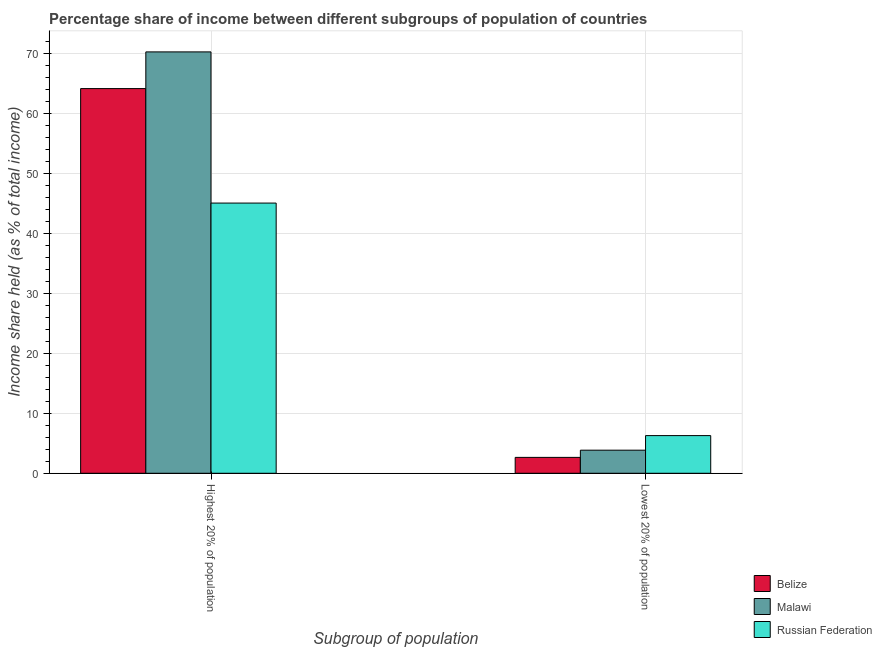How many different coloured bars are there?
Your response must be concise. 3. Are the number of bars on each tick of the X-axis equal?
Your response must be concise. Yes. How many bars are there on the 2nd tick from the left?
Your response must be concise. 3. What is the label of the 2nd group of bars from the left?
Ensure brevity in your answer.  Lowest 20% of population. What is the income share held by highest 20% of the population in Belize?
Your answer should be very brief. 64.15. Across all countries, what is the maximum income share held by highest 20% of the population?
Your response must be concise. 70.27. Across all countries, what is the minimum income share held by highest 20% of the population?
Your answer should be very brief. 45.06. In which country was the income share held by lowest 20% of the population maximum?
Make the answer very short. Russian Federation. In which country was the income share held by highest 20% of the population minimum?
Give a very brief answer. Russian Federation. What is the total income share held by lowest 20% of the population in the graph?
Keep it short and to the point. 12.78. What is the difference between the income share held by lowest 20% of the population in Malawi and that in Russian Federation?
Offer a terse response. -2.43. What is the difference between the income share held by lowest 20% of the population in Malawi and the income share held by highest 20% of the population in Belize?
Your answer should be compact. -60.3. What is the average income share held by highest 20% of the population per country?
Your response must be concise. 59.83. What is the difference between the income share held by highest 20% of the population and income share held by lowest 20% of the population in Malawi?
Provide a succinct answer. 66.42. What is the ratio of the income share held by highest 20% of the population in Malawi to that in Russian Federation?
Your answer should be compact. 1.56. Is the income share held by highest 20% of the population in Russian Federation less than that in Malawi?
Give a very brief answer. Yes. In how many countries, is the income share held by highest 20% of the population greater than the average income share held by highest 20% of the population taken over all countries?
Your response must be concise. 2. What does the 1st bar from the left in Highest 20% of population represents?
Give a very brief answer. Belize. What does the 1st bar from the right in Lowest 20% of population represents?
Offer a very short reply. Russian Federation. Are all the bars in the graph horizontal?
Keep it short and to the point. No. What is the difference between two consecutive major ticks on the Y-axis?
Give a very brief answer. 10. Are the values on the major ticks of Y-axis written in scientific E-notation?
Your answer should be very brief. No. What is the title of the graph?
Your response must be concise. Percentage share of income between different subgroups of population of countries. What is the label or title of the X-axis?
Provide a short and direct response. Subgroup of population. What is the label or title of the Y-axis?
Your response must be concise. Income share held (as % of total income). What is the Income share held (as % of total income) of Belize in Highest 20% of population?
Offer a terse response. 64.15. What is the Income share held (as % of total income) in Malawi in Highest 20% of population?
Provide a succinct answer. 70.27. What is the Income share held (as % of total income) of Russian Federation in Highest 20% of population?
Provide a succinct answer. 45.06. What is the Income share held (as % of total income) of Belize in Lowest 20% of population?
Offer a very short reply. 2.65. What is the Income share held (as % of total income) in Malawi in Lowest 20% of population?
Ensure brevity in your answer.  3.85. What is the Income share held (as % of total income) in Russian Federation in Lowest 20% of population?
Your answer should be very brief. 6.28. Across all Subgroup of population, what is the maximum Income share held (as % of total income) of Belize?
Make the answer very short. 64.15. Across all Subgroup of population, what is the maximum Income share held (as % of total income) of Malawi?
Offer a terse response. 70.27. Across all Subgroup of population, what is the maximum Income share held (as % of total income) of Russian Federation?
Offer a terse response. 45.06. Across all Subgroup of population, what is the minimum Income share held (as % of total income) in Belize?
Your answer should be compact. 2.65. Across all Subgroup of population, what is the minimum Income share held (as % of total income) in Malawi?
Provide a short and direct response. 3.85. Across all Subgroup of population, what is the minimum Income share held (as % of total income) of Russian Federation?
Provide a succinct answer. 6.28. What is the total Income share held (as % of total income) of Belize in the graph?
Give a very brief answer. 66.8. What is the total Income share held (as % of total income) in Malawi in the graph?
Make the answer very short. 74.12. What is the total Income share held (as % of total income) of Russian Federation in the graph?
Provide a short and direct response. 51.34. What is the difference between the Income share held (as % of total income) of Belize in Highest 20% of population and that in Lowest 20% of population?
Your answer should be very brief. 61.5. What is the difference between the Income share held (as % of total income) in Malawi in Highest 20% of population and that in Lowest 20% of population?
Give a very brief answer. 66.42. What is the difference between the Income share held (as % of total income) of Russian Federation in Highest 20% of population and that in Lowest 20% of population?
Offer a terse response. 38.78. What is the difference between the Income share held (as % of total income) in Belize in Highest 20% of population and the Income share held (as % of total income) in Malawi in Lowest 20% of population?
Provide a succinct answer. 60.3. What is the difference between the Income share held (as % of total income) in Belize in Highest 20% of population and the Income share held (as % of total income) in Russian Federation in Lowest 20% of population?
Your response must be concise. 57.87. What is the difference between the Income share held (as % of total income) of Malawi in Highest 20% of population and the Income share held (as % of total income) of Russian Federation in Lowest 20% of population?
Keep it short and to the point. 63.99. What is the average Income share held (as % of total income) in Belize per Subgroup of population?
Your answer should be very brief. 33.4. What is the average Income share held (as % of total income) in Malawi per Subgroup of population?
Offer a terse response. 37.06. What is the average Income share held (as % of total income) in Russian Federation per Subgroup of population?
Provide a succinct answer. 25.67. What is the difference between the Income share held (as % of total income) of Belize and Income share held (as % of total income) of Malawi in Highest 20% of population?
Ensure brevity in your answer.  -6.12. What is the difference between the Income share held (as % of total income) of Belize and Income share held (as % of total income) of Russian Federation in Highest 20% of population?
Offer a terse response. 19.09. What is the difference between the Income share held (as % of total income) in Malawi and Income share held (as % of total income) in Russian Federation in Highest 20% of population?
Ensure brevity in your answer.  25.21. What is the difference between the Income share held (as % of total income) in Belize and Income share held (as % of total income) in Malawi in Lowest 20% of population?
Keep it short and to the point. -1.2. What is the difference between the Income share held (as % of total income) in Belize and Income share held (as % of total income) in Russian Federation in Lowest 20% of population?
Give a very brief answer. -3.63. What is the difference between the Income share held (as % of total income) of Malawi and Income share held (as % of total income) of Russian Federation in Lowest 20% of population?
Offer a terse response. -2.43. What is the ratio of the Income share held (as % of total income) of Belize in Highest 20% of population to that in Lowest 20% of population?
Your answer should be compact. 24.21. What is the ratio of the Income share held (as % of total income) in Malawi in Highest 20% of population to that in Lowest 20% of population?
Offer a very short reply. 18.25. What is the ratio of the Income share held (as % of total income) in Russian Federation in Highest 20% of population to that in Lowest 20% of population?
Provide a succinct answer. 7.18. What is the difference between the highest and the second highest Income share held (as % of total income) of Belize?
Provide a short and direct response. 61.5. What is the difference between the highest and the second highest Income share held (as % of total income) in Malawi?
Your answer should be very brief. 66.42. What is the difference between the highest and the second highest Income share held (as % of total income) in Russian Federation?
Give a very brief answer. 38.78. What is the difference between the highest and the lowest Income share held (as % of total income) of Belize?
Give a very brief answer. 61.5. What is the difference between the highest and the lowest Income share held (as % of total income) in Malawi?
Make the answer very short. 66.42. What is the difference between the highest and the lowest Income share held (as % of total income) in Russian Federation?
Your answer should be compact. 38.78. 